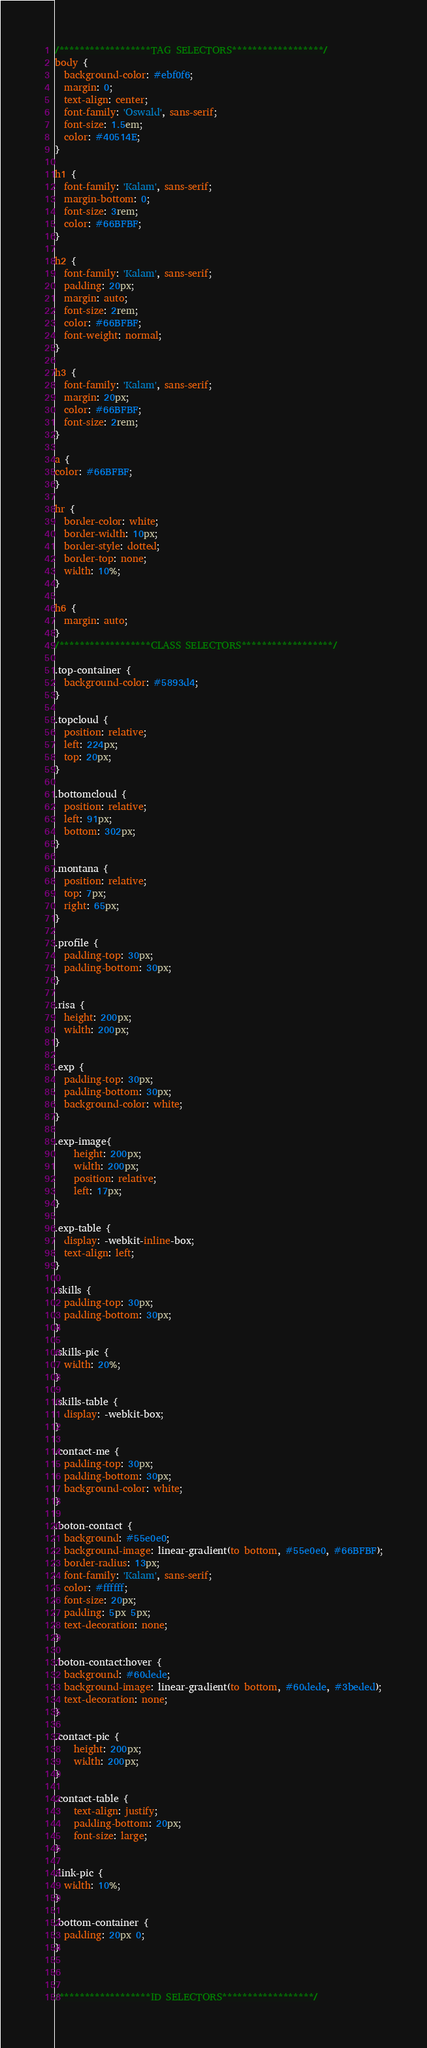<code> <loc_0><loc_0><loc_500><loc_500><_CSS_>/******************TAG SELECTORS******************/
body {
  background-color: #ebf0f6;
  margin: 0;
  text-align: center;
  font-family: 'Oswald', sans-serif;
  font-size: 1.5em;
  color: #40514E;
}

h1 {
  font-family: 'Kalam', sans-serif;
  margin-bottom: 0;
  font-size: 3rem;
  color: #66BFBF;
}

h2 {
  font-family: 'Kalam', sans-serif;
  padding: 20px;
  margin: auto;
  font-size: 2rem;
  color: #66BFBF;
  font-weight: normal;
}

h3 {
  font-family: 'Kalam', sans-serif;
  margin: 20px;
  color: #66BFBF;
  font-size: 2rem;
}

a {
color: #66BFBF;
}

hr {
  border-color: white;
  border-width: 10px;
  border-style: dotted;
  border-top: none;
  width: 10%;
}

h6 {
  margin: auto;
}
/******************CLASS SELECTORS******************/

.top-container {
  background-color: #5893d4;
}

.topcloud {
  position: relative;
  left: 224px;
  top: 20px;
}

.bottomcloud {
  position: relative;
  left: 91px;
  bottom: 302px;
}

.montana {
  position: relative;
  top: 7px;
  right: 65px;
}

.profile {
  padding-top: 30px;
  padding-bottom: 30px;
}

.risa {
  height: 200px;
  width: 200px;
}

.exp {
  padding-top: 30px;
  padding-bottom: 30px;
  background-color: white;
}

.exp-image{
    height: 200px;
    width: 200px;
    position: relative;
    left: 17px;
}

.exp-table {
  display: -webkit-inline-box;
  text-align: left;
}

.skills {
  padding-top: 30px;
  padding-bottom: 30px;
}

.skills-pic {
  width: 20%;
}

.skills-table {
  display: -webkit-box;
}

.contact-me {
  padding-top: 30px;
  padding-bottom: 30px;
  background-color: white;
}

.boton-contact {
  background: #55e0e0;
  background-image: linear-gradient(to bottom, #55e0e0, #66BFBF);
  border-radius: 13px;
  font-family: 'Kalam', sans-serif;
  color: #ffffff;
  font-size: 20px;
  padding: 5px 5px;
  text-decoration: none;
}

.boton-contact:hover {
  background: #60dede;
  background-image: linear-gradient(to bottom, #60dede, #3beded);
  text-decoration: none;
}

.contact-pic {
    height: 200px;
    width: 200px;
}

.contact-table {
    text-align: justify;
    padding-bottom: 20px;
    font-size: large;
}

.link-pic {
  width: 10%;
}

.bottom-container {
  padding: 20px 0;
}



/******************ID SELECTORS******************/
</code> 